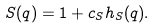<formula> <loc_0><loc_0><loc_500><loc_500>S ( q ) = 1 + c _ { S } h _ { S } ( q ) .</formula> 